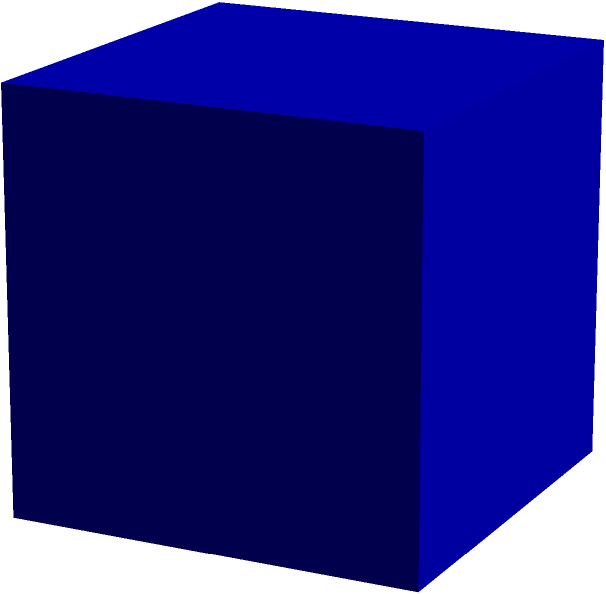As a police officer, you're tasked with calculating the surface area of a new cube-shaped holding cell in the precinct. The cell has an edge length of 3 meters. What is the total surface area of this holding cell? Let's approach this step-by-step:

1) The formula for the surface area of a cube is:
   $$SA = 6a^2$$
   where $a$ is the length of one edge.

2) We're given that the edge length is 3 meters, so $a = 3$.

3) Let's substitute this into our formula:
   $$SA = 6(3^2)$$

4) First, let's calculate $3^2$:
   $$3^2 = 3 \times 3 = 9$$

5) Now our equation looks like this:
   $$SA = 6 \times 9$$

6) Finally, let's multiply:
   $$SA = 54$$

Therefore, the surface area of the holding cell is 54 square meters.
Answer: 54 m² 